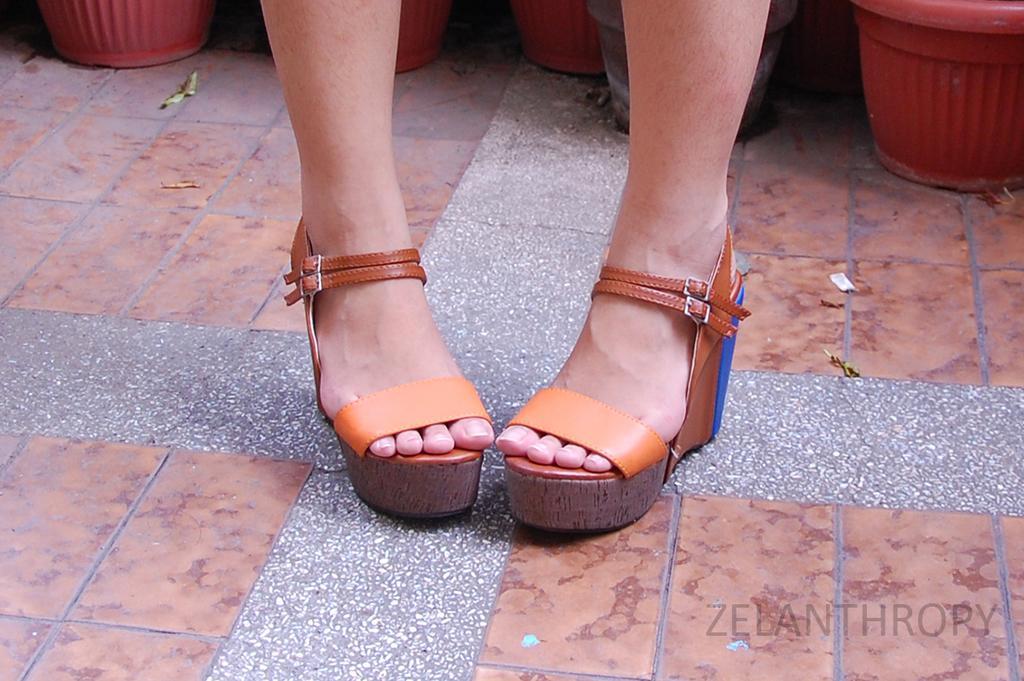Can you describe this image briefly? In the image we can see two legs and footwear. Behind the legs there are some flower pots. 